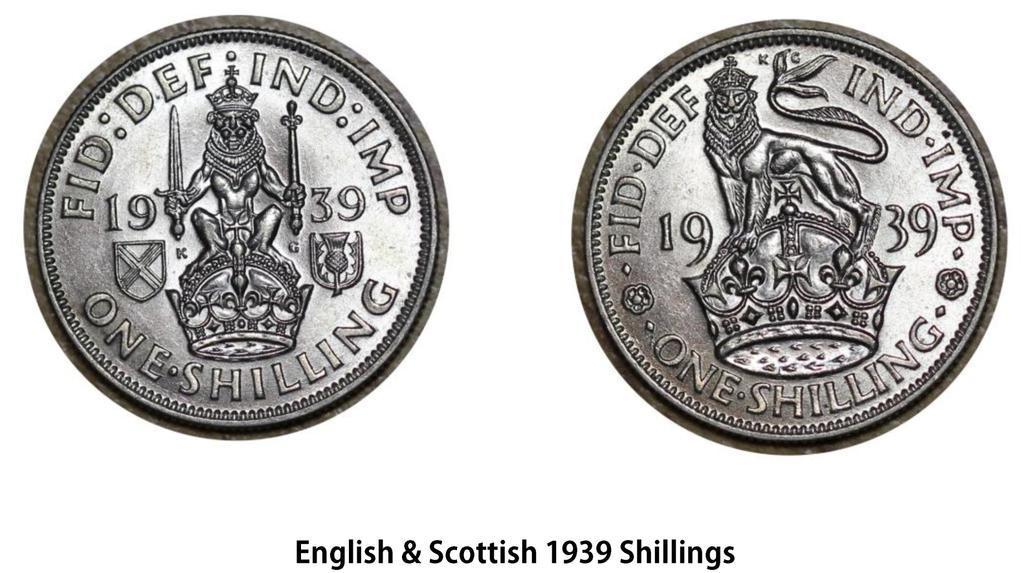<image>
Write a terse but informative summary of the picture. both sides of an english and scottish shilling from 1939 